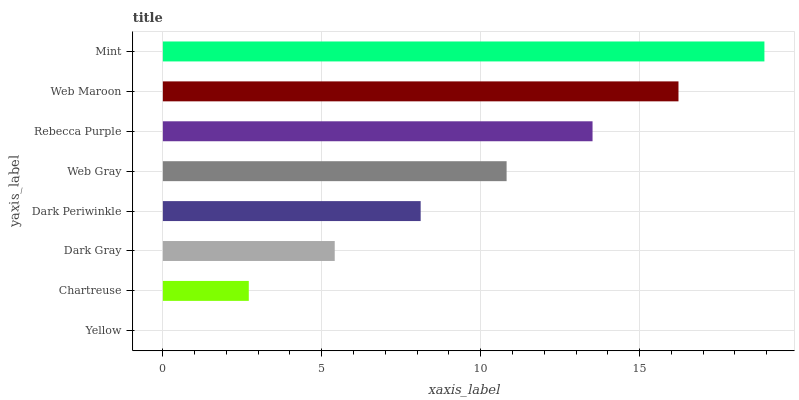Is Yellow the minimum?
Answer yes or no. Yes. Is Mint the maximum?
Answer yes or no. Yes. Is Chartreuse the minimum?
Answer yes or no. No. Is Chartreuse the maximum?
Answer yes or no. No. Is Chartreuse greater than Yellow?
Answer yes or no. Yes. Is Yellow less than Chartreuse?
Answer yes or no. Yes. Is Yellow greater than Chartreuse?
Answer yes or no. No. Is Chartreuse less than Yellow?
Answer yes or no. No. Is Web Gray the high median?
Answer yes or no. Yes. Is Dark Periwinkle the low median?
Answer yes or no. Yes. Is Mint the high median?
Answer yes or no. No. Is Mint the low median?
Answer yes or no. No. 